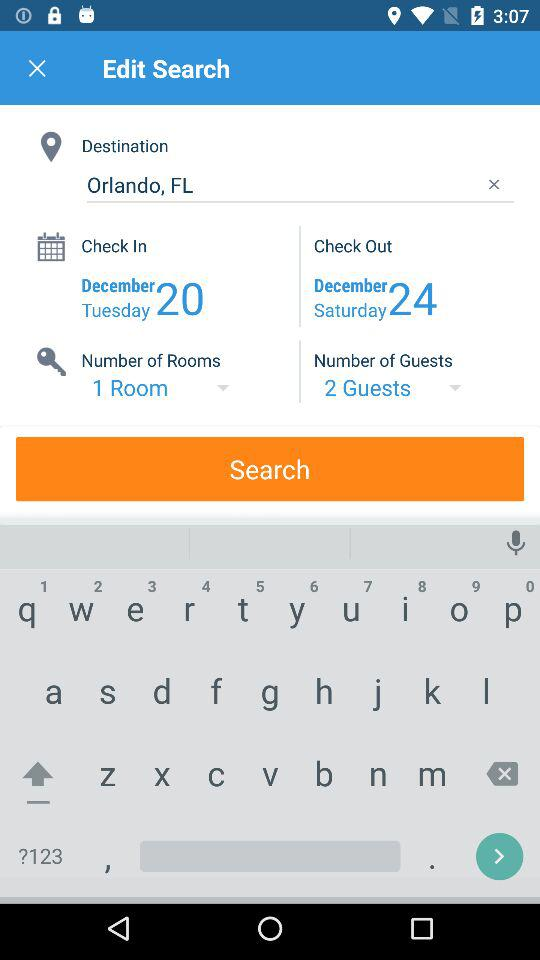What is the check-in date? The check-in date is Tuesday, December 20. 